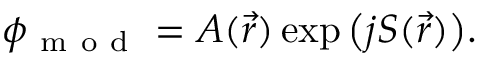Convert formula to latex. <formula><loc_0><loc_0><loc_500><loc_500>\phi _ { m o d } = A ( \vec { r } ) \exp { \left ( j S ( \vec { r } ) \right ) } .</formula> 